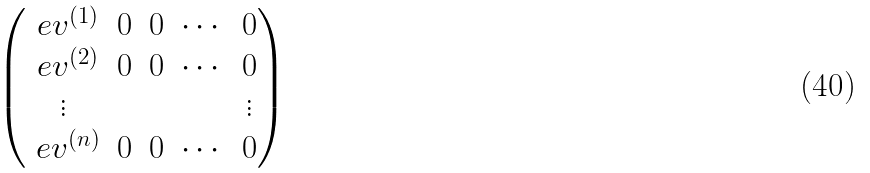<formula> <loc_0><loc_0><loc_500><loc_500>\begin{pmatrix} \ e v ^ { ( 1 ) } & 0 & 0 & \cdots & 0 \\ \ e v ^ { ( 2 ) } & 0 & 0 & \cdots & 0 \\ \vdots & & & & \vdots \\ \ e v ^ { ( n ) } & 0 & 0 & \cdots & 0 \end{pmatrix}</formula> 